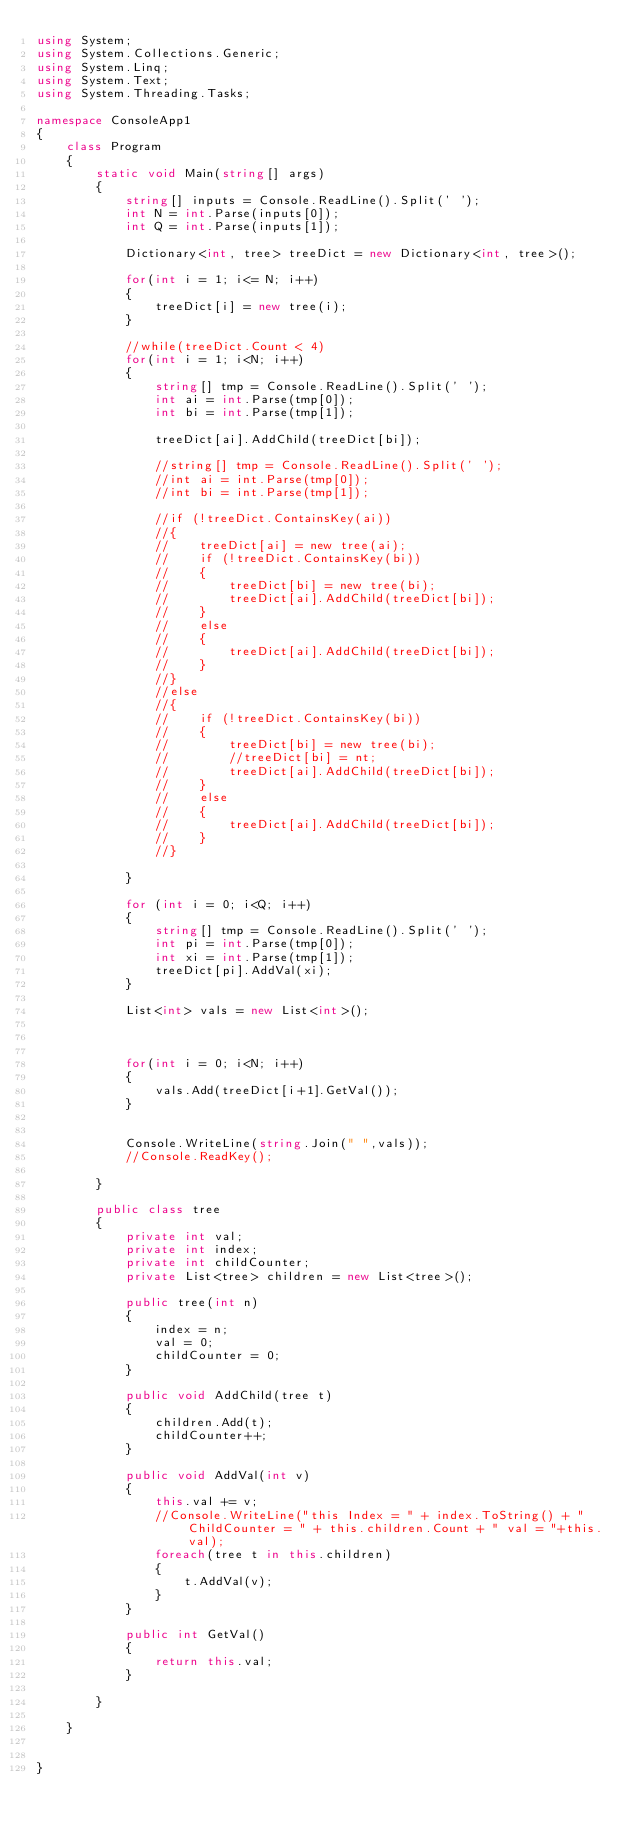<code> <loc_0><loc_0><loc_500><loc_500><_C#_>using System;
using System.Collections.Generic;
using System.Linq;
using System.Text;
using System.Threading.Tasks;

namespace ConsoleApp1
{
    class Program
    {
        static void Main(string[] args)
        {
            string[] inputs = Console.ReadLine().Split(' ');
            int N = int.Parse(inputs[0]);
            int Q = int.Parse(inputs[1]);

            Dictionary<int, tree> treeDict = new Dictionary<int, tree>();

            for(int i = 1; i<= N; i++)
            {
                treeDict[i] = new tree(i);
            }

            //while(treeDict.Count < 4)
            for(int i = 1; i<N; i++)
            {
                string[] tmp = Console.ReadLine().Split(' ');
                int ai = int.Parse(tmp[0]);
                int bi = int.Parse(tmp[1]);

                treeDict[ai].AddChild(treeDict[bi]);

                //string[] tmp = Console.ReadLine().Split(' ');
                //int ai = int.Parse(tmp[0]);
                //int bi = int.Parse(tmp[1]);

                //if (!treeDict.ContainsKey(ai))
                //{
                //    treeDict[ai] = new tree(ai);
                //    if (!treeDict.ContainsKey(bi))
                //    {
                //        treeDict[bi] = new tree(bi);
                //        treeDict[ai].AddChild(treeDict[bi]);
                //    }
                //    else
                //    {
                //        treeDict[ai].AddChild(treeDict[bi]);
                //    }
                //}
                //else
                //{
                //    if (!treeDict.ContainsKey(bi))
                //    {
                //        treeDict[bi] = new tree(bi);
                //        //treeDict[bi] = nt;
                //        treeDict[ai].AddChild(treeDict[bi]);
                //    }
                //    else
                //    {
                //        treeDict[ai].AddChild(treeDict[bi]);
                //    }
                //}

            }

            for (int i = 0; i<Q; i++)
            {
                string[] tmp = Console.ReadLine().Split(' ');
                int pi = int.Parse(tmp[0]);
                int xi = int.Parse(tmp[1]);
                treeDict[pi].AddVal(xi);
            }

            List<int> vals = new List<int>();
            


            for(int i = 0; i<N; i++)
            {
                vals.Add(treeDict[i+1].GetVal());
            }


            Console.WriteLine(string.Join(" ",vals));
            //Console.ReadKey();

        }

        public class tree
        {
            private int val;
            private int index;
            private int childCounter;
            private List<tree> children = new List<tree>();

            public tree(int n)
            {
                index = n;
                val = 0;
                childCounter = 0;
            }

            public void AddChild(tree t)
            {
                children.Add(t);
                childCounter++;
            }

            public void AddVal(int v)
            {
                this.val += v;
                //Console.WriteLine("this Index = " + index.ToString() + "  ChildCounter = " + this.children.Count + " val = "+this.val);
                foreach(tree t in this.children)
                {
                    t.AddVal(v);
                }
            }

            public int GetVal()
            {
                return this.val;
            }

        }

    }


}
</code> 